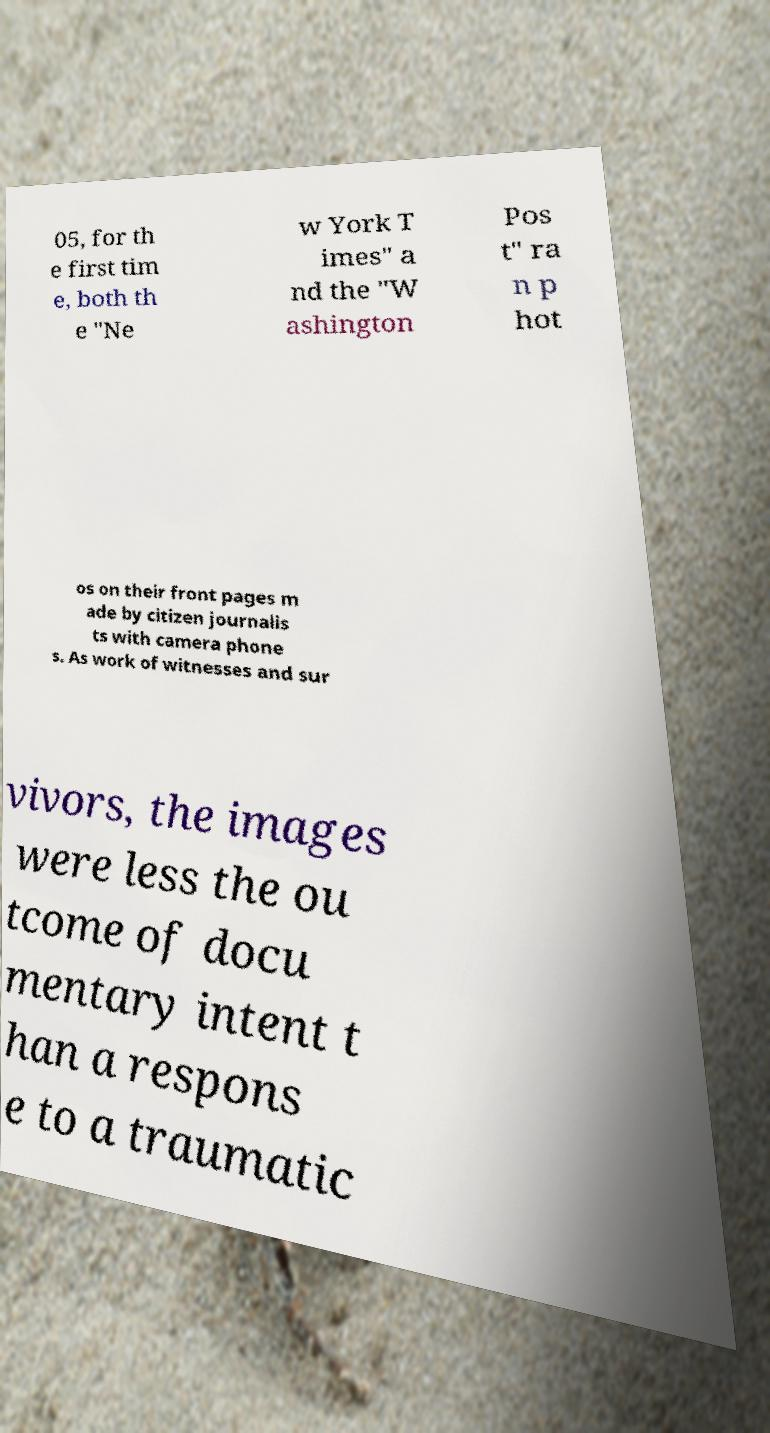Could you extract and type out the text from this image? 05, for th e first tim e, both th e "Ne w York T imes" a nd the "W ashington Pos t" ra n p hot os on their front pages m ade by citizen journalis ts with camera phone s. As work of witnesses and sur vivors, the images were less the ou tcome of docu mentary intent t han a respons e to a traumatic 